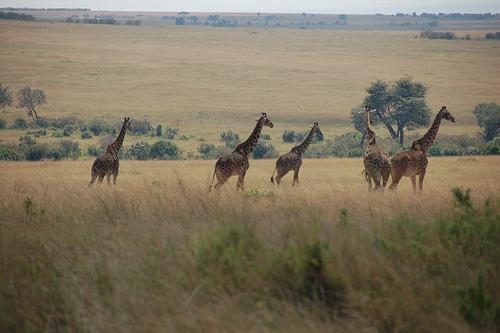How many giraffes are there?
Give a very brief answer. 5. 